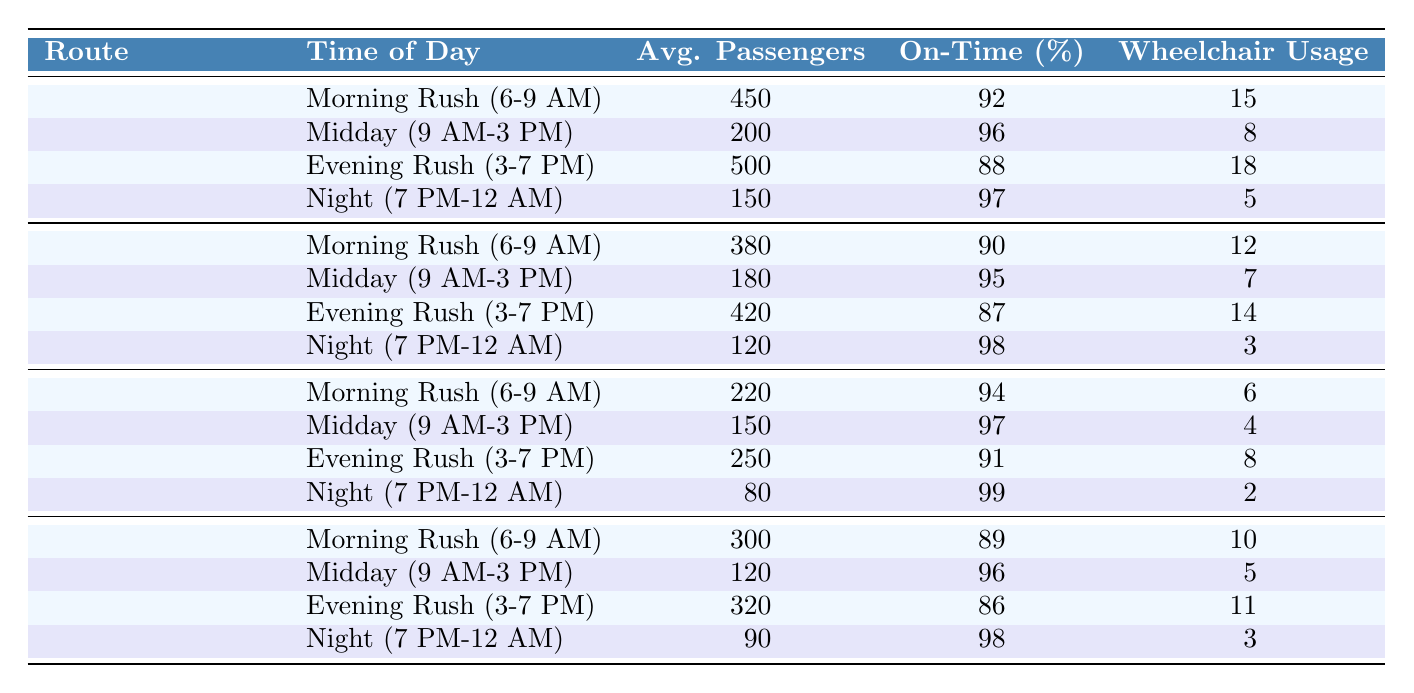What is the average number of passengers on the Blue Line during the Evening Rush? The average number of passengers on the Blue Line during the Evening Rush (3-7 PM) is listed as 500 in the table.
Answer: 500 Which route has the highest On-Time Performance percentage during Night time? The table shows that the Downtown Shuttle has the highest On-Time Performance percentage of 99% during Night (7 PM-12 AM).
Answer: Downtown Shuttle What is the total average passengers for the Green Route throughout the day? To find the total average passengers for the Green Route, we sum the averages: 380 (Morning) + 180 (Midday) + 420 (Evening) + 120 (Night) = 1100, and this total represents the average passengers for the entire day.
Answer: 1100 Is the wheelchair accessibility usage higher for the Downtown Shuttle or the Crosstown Express during the Morning Rush? The Downtown Shuttle has 6 wheelchair accessibility usages during the Morning Rush, while the Crosstown Express has 10. Since 10 is greater than 6, the Crosstown Express has higher usage.
Answer: Yes What is the average On-Time Performance for the Blue Line across all times of day? To find this, we average the On-Time Performance percentages: (92 + 96 + 88 + 97) / 4 = 93.25% when calculated. Thus, the average On-Time Performance for the Blue Line is approximately 93.25%.
Answer: 93.25% During which time of day is the Green Route least used based on average passengers? The average passengers for the Green Route shows 120 during Night (7 PM-12 AM), which is less than all other times, indicating it is the least used.
Answer: Night How many average passengers does the Crosstown Express have during the Midday compared to the Night? The average passengers for the Crosstown Express during Midday is 120, while during Night it is 90. The difference is 120 - 90 = 30, showing it has 30 more average passengers during Midday.
Answer: 30 Is the average wheelchair accessibility usage for the Evening Rush on the Blue Line equal to that of the Green Route? The Blue Line has 18 wheelchair accessibility usages during the Evening Rush, while the Green Route has 14. Therefore, they are not equal, as 18 is greater than 14.
Answer: No 